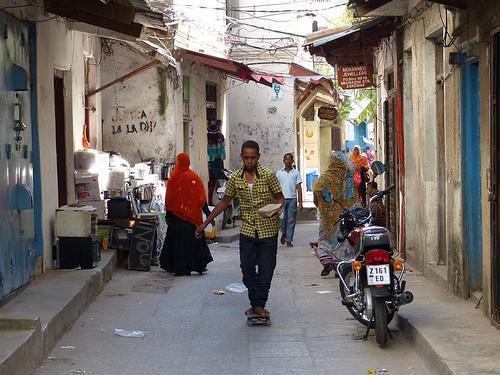How many people are in the picture?
Give a very brief answer. 5. How many wheels are visible in the picture?
Give a very brief answer. 4. 